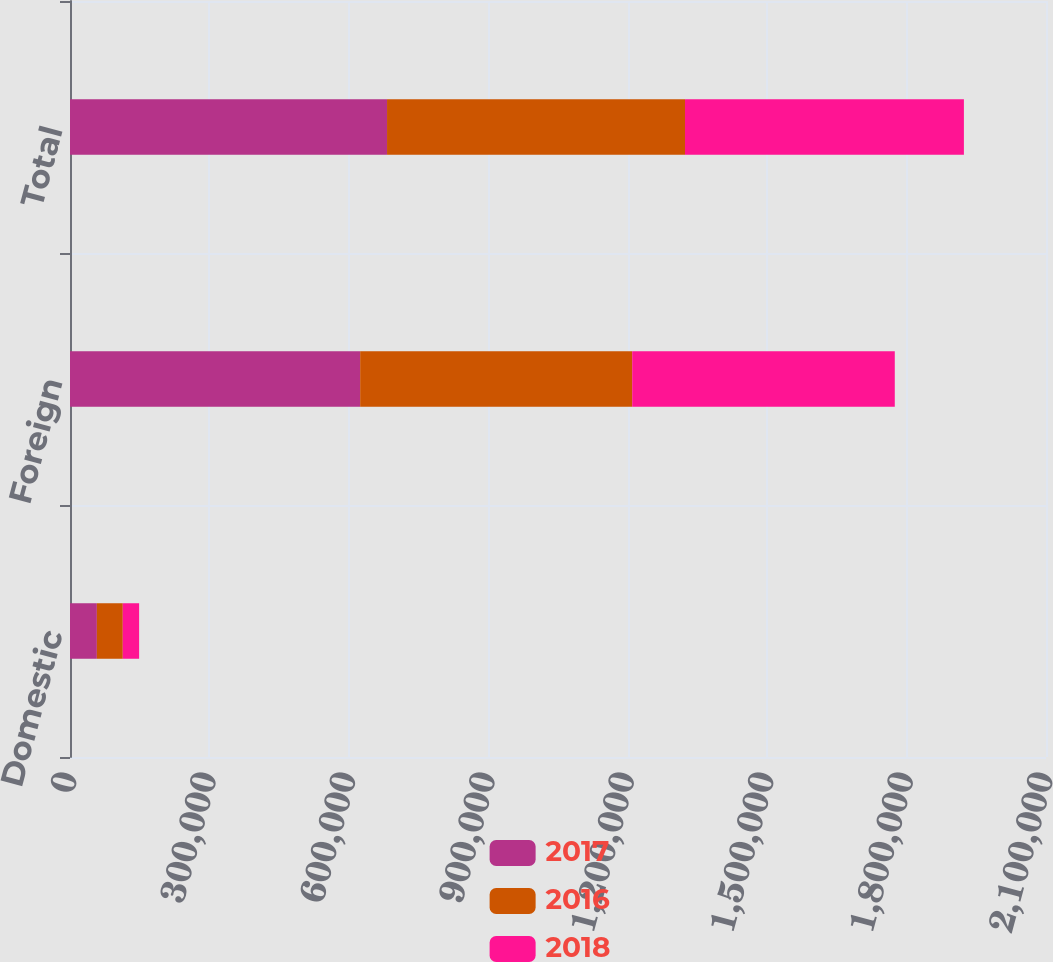Convert chart to OTSL. <chart><loc_0><loc_0><loc_500><loc_500><stacked_bar_chart><ecel><fcel>Domestic<fcel>Foreign<fcel>Total<nl><fcel>2017<fcel>57822<fcel>624324<fcel>682146<nl><fcel>2016<fcel>55751<fcel>585346<fcel>641097<nl><fcel>2018<fcel>35154<fcel>564960<fcel>600114<nl></chart> 